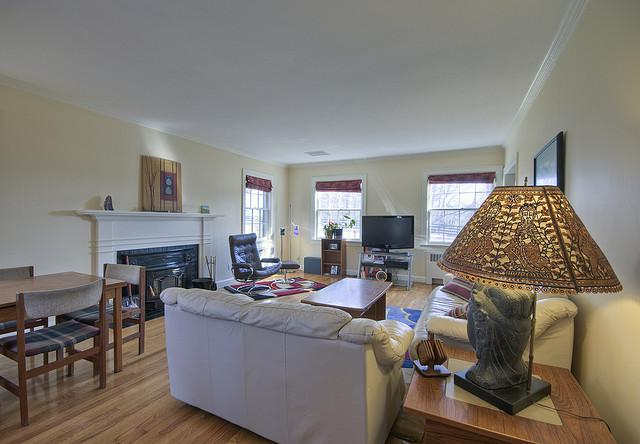What color are the sofa seats surrounding the table on the rug? Please explain your reasoning. cream. This is a common colour for furniture. 